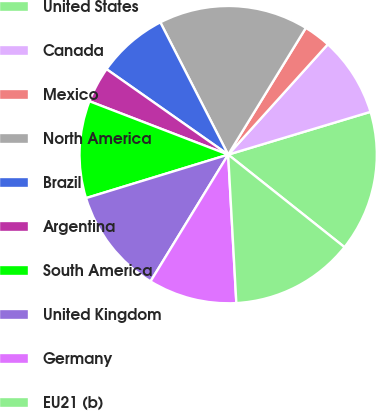Convert chart. <chart><loc_0><loc_0><loc_500><loc_500><pie_chart><fcel>United States<fcel>Canada<fcel>Mexico<fcel>North America<fcel>Brazil<fcel>Argentina<fcel>South America<fcel>United Kingdom<fcel>Germany<fcel>EU21 (b)<nl><fcel>15.34%<fcel>8.66%<fcel>2.94%<fcel>16.29%<fcel>7.71%<fcel>3.9%<fcel>10.57%<fcel>11.53%<fcel>9.62%<fcel>13.43%<nl></chart> 